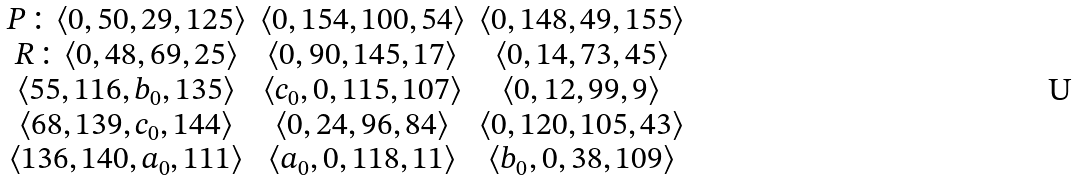<formula> <loc_0><loc_0><loc_500><loc_500>\begin{array} { c c c } P \colon \langle 0 , 5 0 , 2 9 , 1 2 5 \rangle & \langle 0 , 1 5 4 , 1 0 0 , 5 4 \rangle & \langle 0 , 1 4 8 , 4 9 , 1 5 5 \rangle \\ R \colon \langle 0 , 4 8 , 6 9 , 2 5 \rangle & \langle 0 , 9 0 , 1 4 5 , 1 7 \rangle & \langle 0 , 1 4 , 7 3 , 4 5 \rangle \\ \langle 5 5 , 1 1 6 , b _ { 0 } , 1 3 5 \rangle & \langle c _ { 0 } , 0 , 1 1 5 , 1 0 7 \rangle & \langle 0 , 1 2 , 9 9 , 9 \rangle \\ \langle 6 8 , 1 3 9 , c _ { 0 } , 1 4 4 \rangle & \langle 0 , 2 4 , 9 6 , 8 4 \rangle & \langle 0 , 1 2 0 , 1 0 5 , 4 3 \rangle \\ \langle 1 3 6 , 1 4 0 , a _ { 0 } , 1 1 1 \rangle & \langle a _ { 0 } , 0 , 1 1 8 , 1 1 \rangle & \langle b _ { 0 } , 0 , 3 8 , 1 0 9 \rangle \\ \end{array}</formula> 